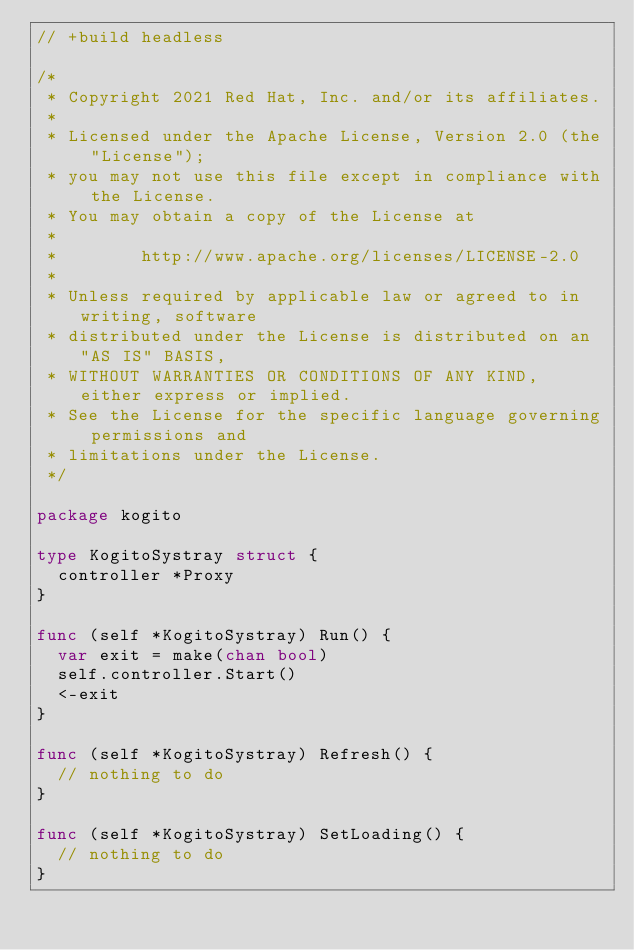Convert code to text. <code><loc_0><loc_0><loc_500><loc_500><_Go_>// +build headless

/*
 * Copyright 2021 Red Hat, Inc. and/or its affiliates.
 *
 * Licensed under the Apache License, Version 2.0 (the "License");
 * you may not use this file except in compliance with the License.
 * You may obtain a copy of the License at
 *
 *        http://www.apache.org/licenses/LICENSE-2.0
 *
 * Unless required by applicable law or agreed to in writing, software
 * distributed under the License is distributed on an "AS IS" BASIS,
 * WITHOUT WARRANTIES OR CONDITIONS OF ANY KIND, either express or implied.
 * See the License for the specific language governing permissions and
 * limitations under the License.
 */

package kogito

type KogitoSystray struct {
	controller *Proxy
}

func (self *KogitoSystray) Run() {
	var exit = make(chan bool)
	self.controller.Start()
	<-exit
}

func (self *KogitoSystray) Refresh() {
	// nothing to do
}

func (self *KogitoSystray) SetLoading() {
	// nothing to do
}
</code> 